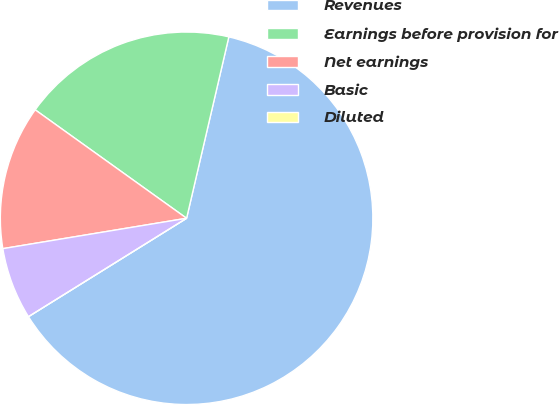<chart> <loc_0><loc_0><loc_500><loc_500><pie_chart><fcel>Revenues<fcel>Earnings before provision for<fcel>Net earnings<fcel>Basic<fcel>Diluted<nl><fcel>62.5%<fcel>18.75%<fcel>12.5%<fcel>6.25%<fcel>0.0%<nl></chart> 